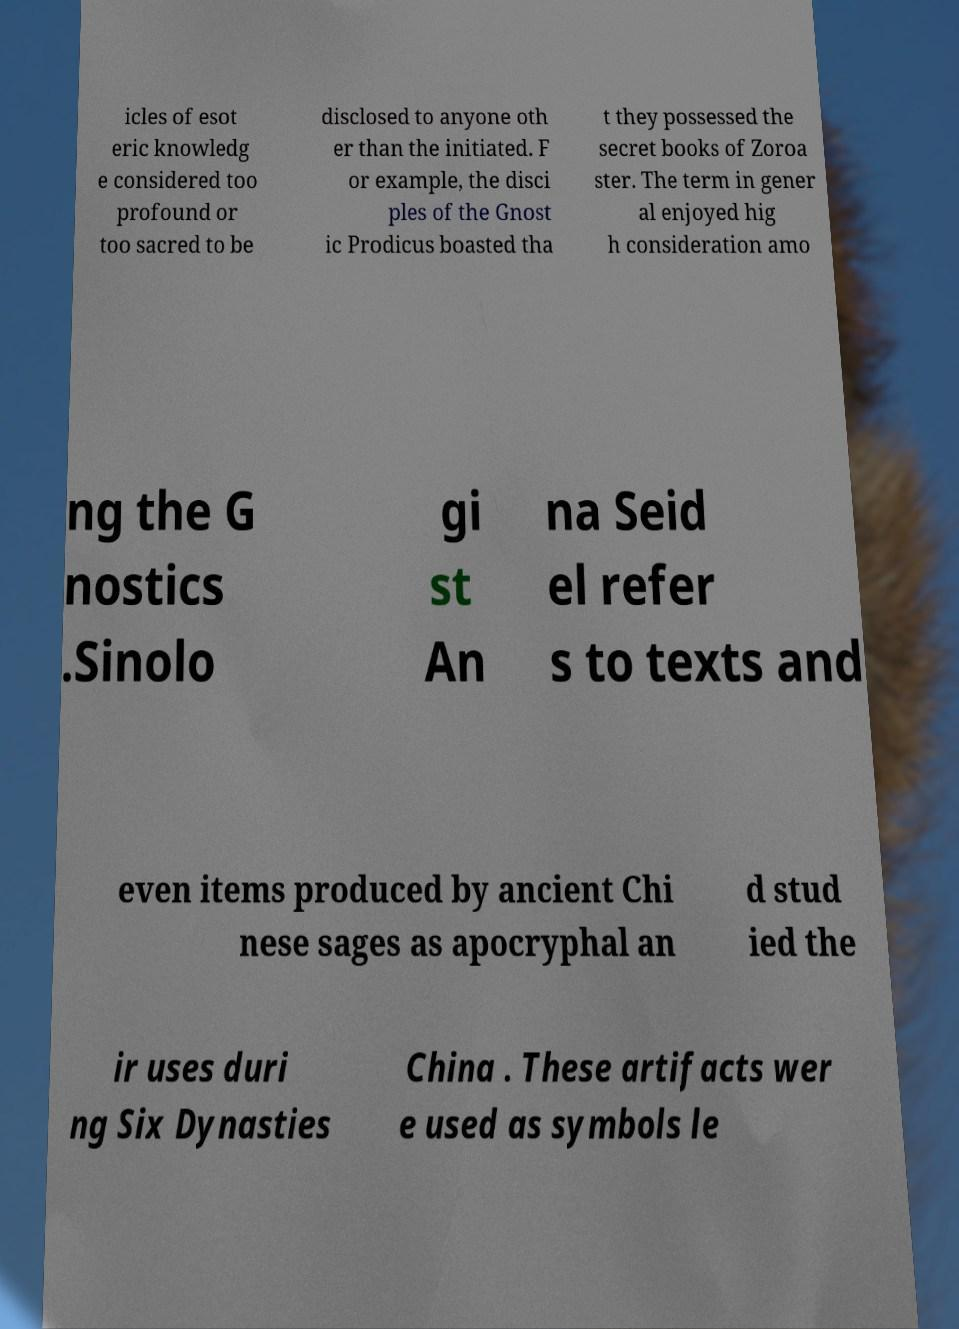Please identify and transcribe the text found in this image. icles of esot eric knowledg e considered too profound or too sacred to be disclosed to anyone oth er than the initiated. F or example, the disci ples of the Gnost ic Prodicus boasted tha t they possessed the secret books of Zoroa ster. The term in gener al enjoyed hig h consideration amo ng the G nostics .Sinolo gi st An na Seid el refer s to texts and even items produced by ancient Chi nese sages as apocryphal an d stud ied the ir uses duri ng Six Dynasties China . These artifacts wer e used as symbols le 